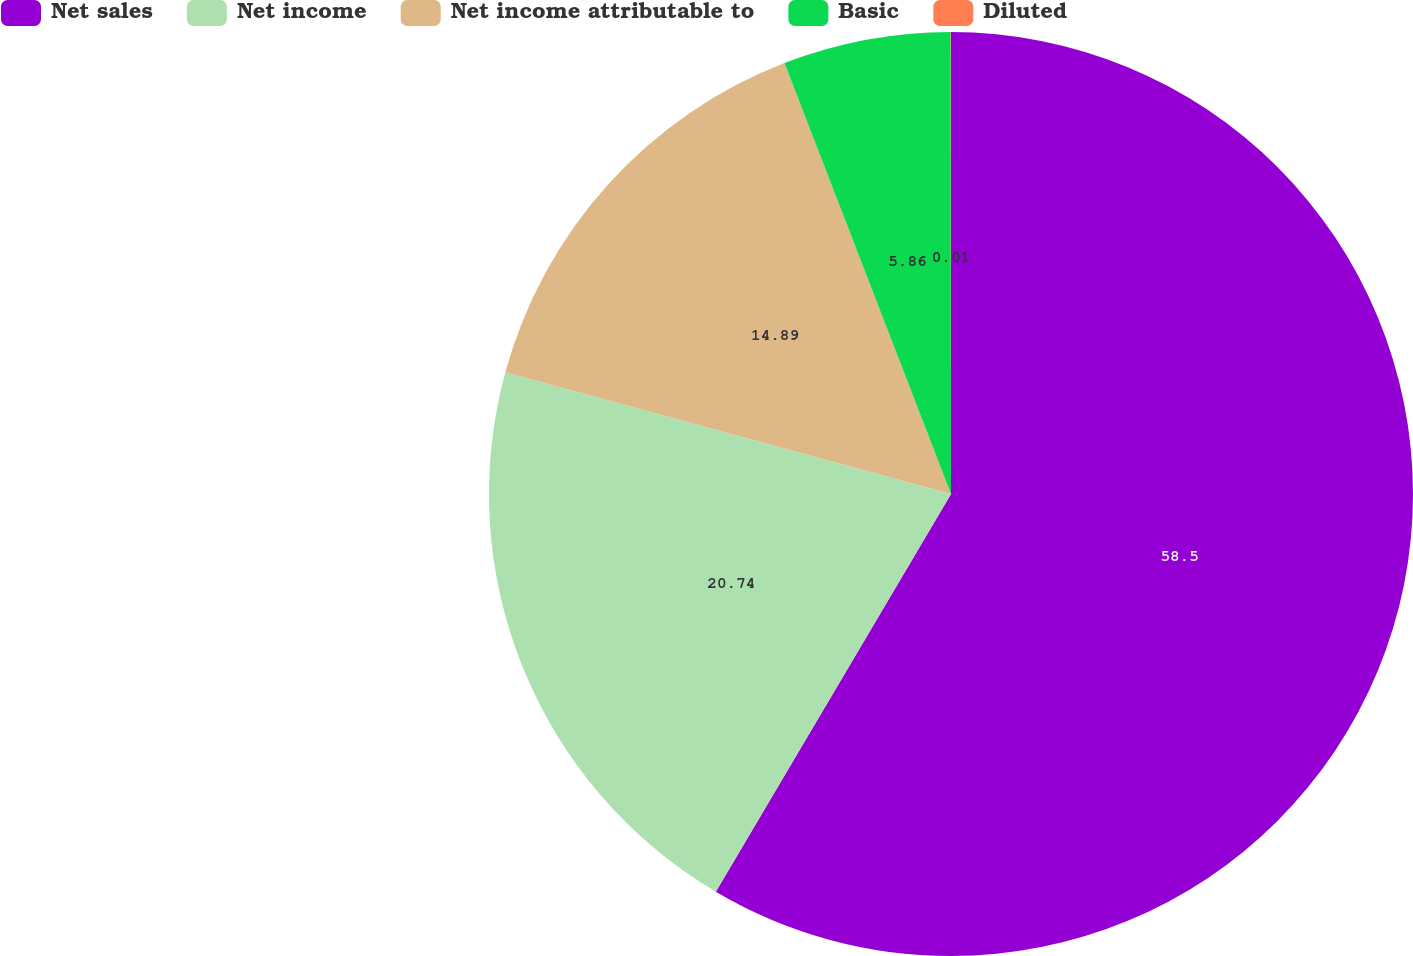Convert chart. <chart><loc_0><loc_0><loc_500><loc_500><pie_chart><fcel>Net sales<fcel>Net income<fcel>Net income attributable to<fcel>Basic<fcel>Diluted<nl><fcel>58.5%<fcel>20.74%<fcel>14.89%<fcel>5.86%<fcel>0.01%<nl></chart> 